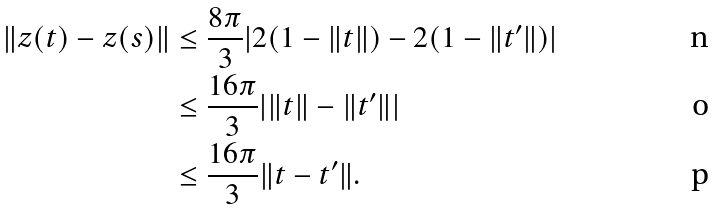<formula> <loc_0><loc_0><loc_500><loc_500>\| z ( t ) - z ( s ) \| & \leq \frac { 8 \pi } { 3 } | 2 ( 1 - \| t \| ) - 2 ( 1 - \| t ^ { \prime } \| ) | \\ & \leq \frac { 1 6 \pi } { 3 } | \| t \| - \| t ^ { \prime } \| | \\ & \leq \frac { 1 6 \pi } { 3 } \| t - t ^ { \prime } \| .</formula> 